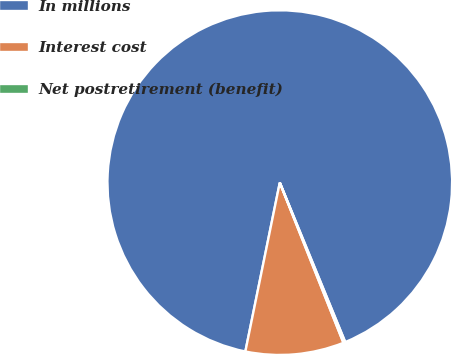Convert chart to OTSL. <chart><loc_0><loc_0><loc_500><loc_500><pie_chart><fcel>In millions<fcel>Interest cost<fcel>Net postretirement (benefit)<nl><fcel>90.6%<fcel>9.22%<fcel>0.18%<nl></chart> 